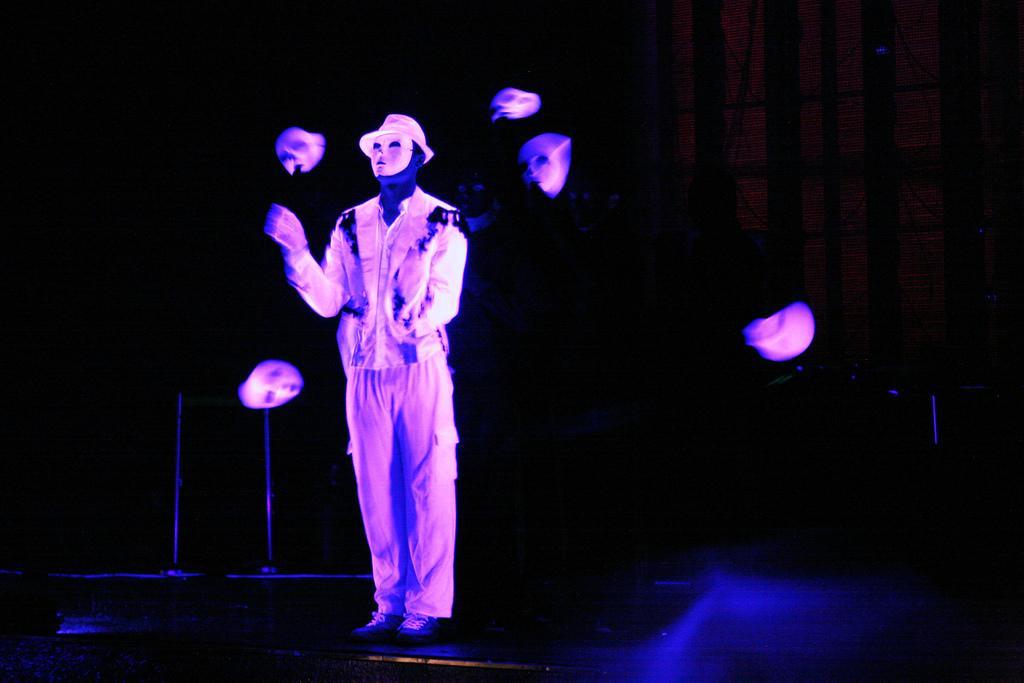How would you summarize this image in a sentence or two? In this picture, we see a man who is wearing a mask and a hat is standing. He is juggling the masks. This might be an edited image. In the background, it is black in color. This picture might be clicked in the dark. 